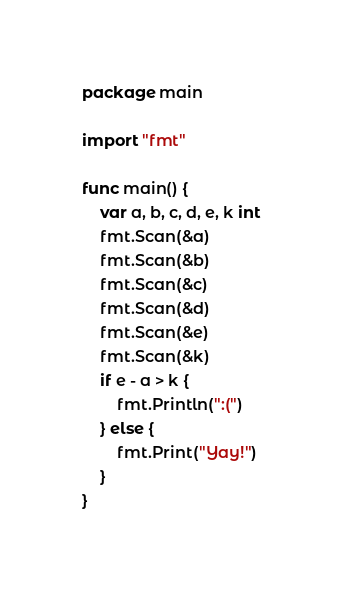Convert code to text. <code><loc_0><loc_0><loc_500><loc_500><_Go_>package main

import "fmt"

func main() {
	var a, b, c, d, e, k int
	fmt.Scan(&a)
	fmt.Scan(&b)
	fmt.Scan(&c)
	fmt.Scan(&d)
	fmt.Scan(&e)
	fmt.Scan(&k)
	if e - a > k {
		fmt.Println(":(")
	} else {
		fmt.Print("Yay!")
	}
}</code> 